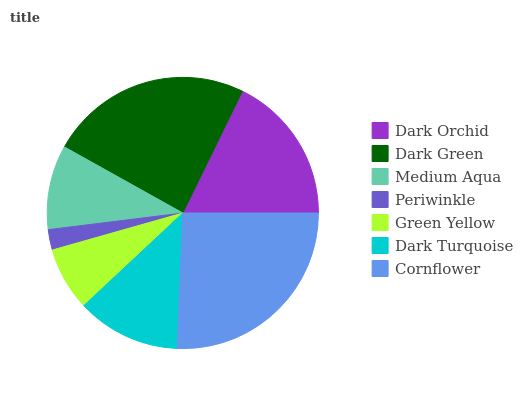Is Periwinkle the minimum?
Answer yes or no. Yes. Is Cornflower the maximum?
Answer yes or no. Yes. Is Dark Green the minimum?
Answer yes or no. No. Is Dark Green the maximum?
Answer yes or no. No. Is Dark Green greater than Dark Orchid?
Answer yes or no. Yes. Is Dark Orchid less than Dark Green?
Answer yes or no. Yes. Is Dark Orchid greater than Dark Green?
Answer yes or no. No. Is Dark Green less than Dark Orchid?
Answer yes or no. No. Is Dark Turquoise the high median?
Answer yes or no. Yes. Is Dark Turquoise the low median?
Answer yes or no. Yes. Is Dark Green the high median?
Answer yes or no. No. Is Medium Aqua the low median?
Answer yes or no. No. 